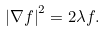Convert formula to latex. <formula><loc_0><loc_0><loc_500><loc_500>\left | \nabla f \right | ^ { 2 } = 2 \lambda f .</formula> 